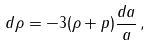Convert formula to latex. <formula><loc_0><loc_0><loc_500><loc_500>d \rho = - 3 ( \rho + p ) \frac { d a } { a } \, ,</formula> 